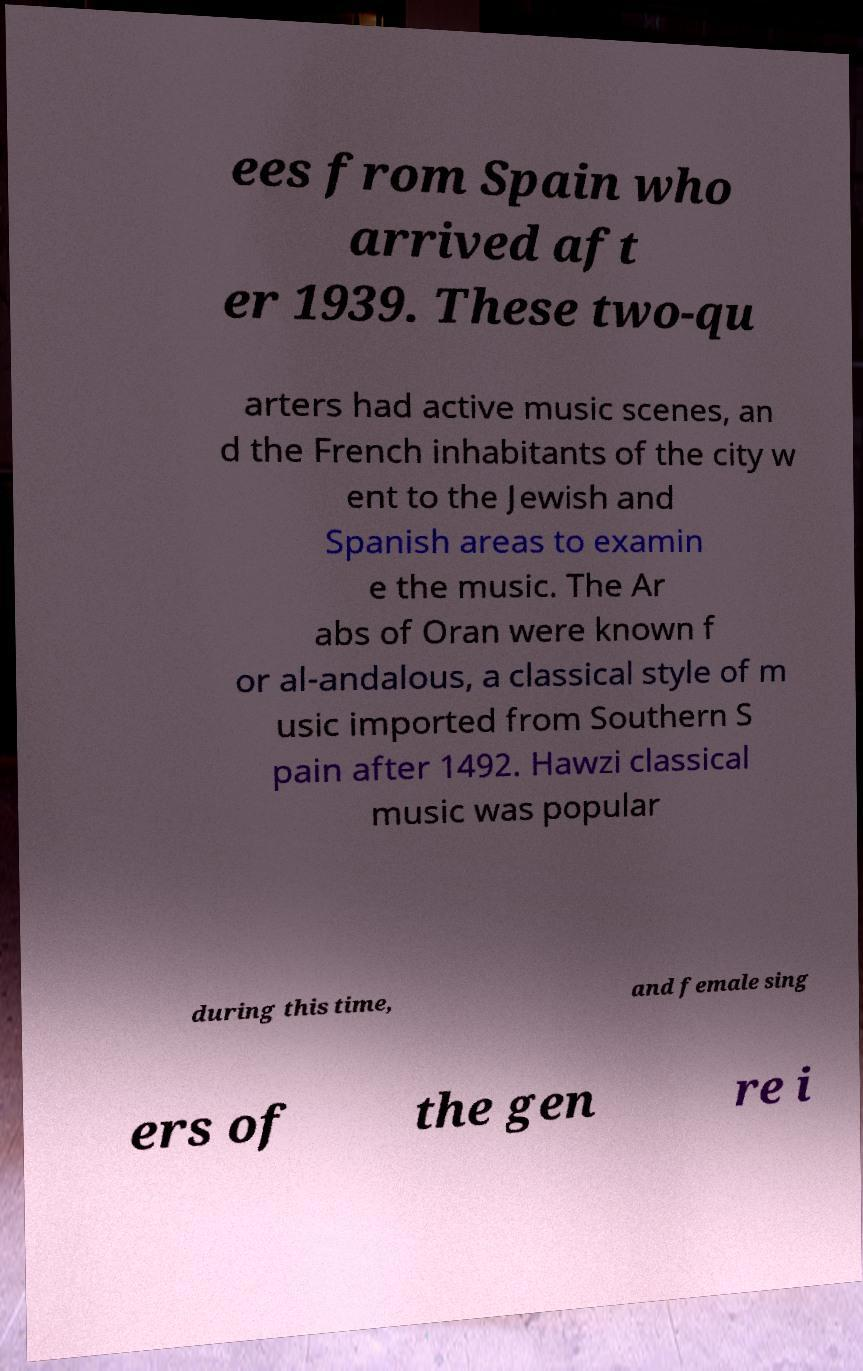Can you read and provide the text displayed in the image?This photo seems to have some interesting text. Can you extract and type it out for me? ees from Spain who arrived aft er 1939. These two-qu arters had active music scenes, an d the French inhabitants of the city w ent to the Jewish and Spanish areas to examin e the music. The Ar abs of Oran were known f or al-andalous, a classical style of m usic imported from Southern S pain after 1492. Hawzi classical music was popular during this time, and female sing ers of the gen re i 